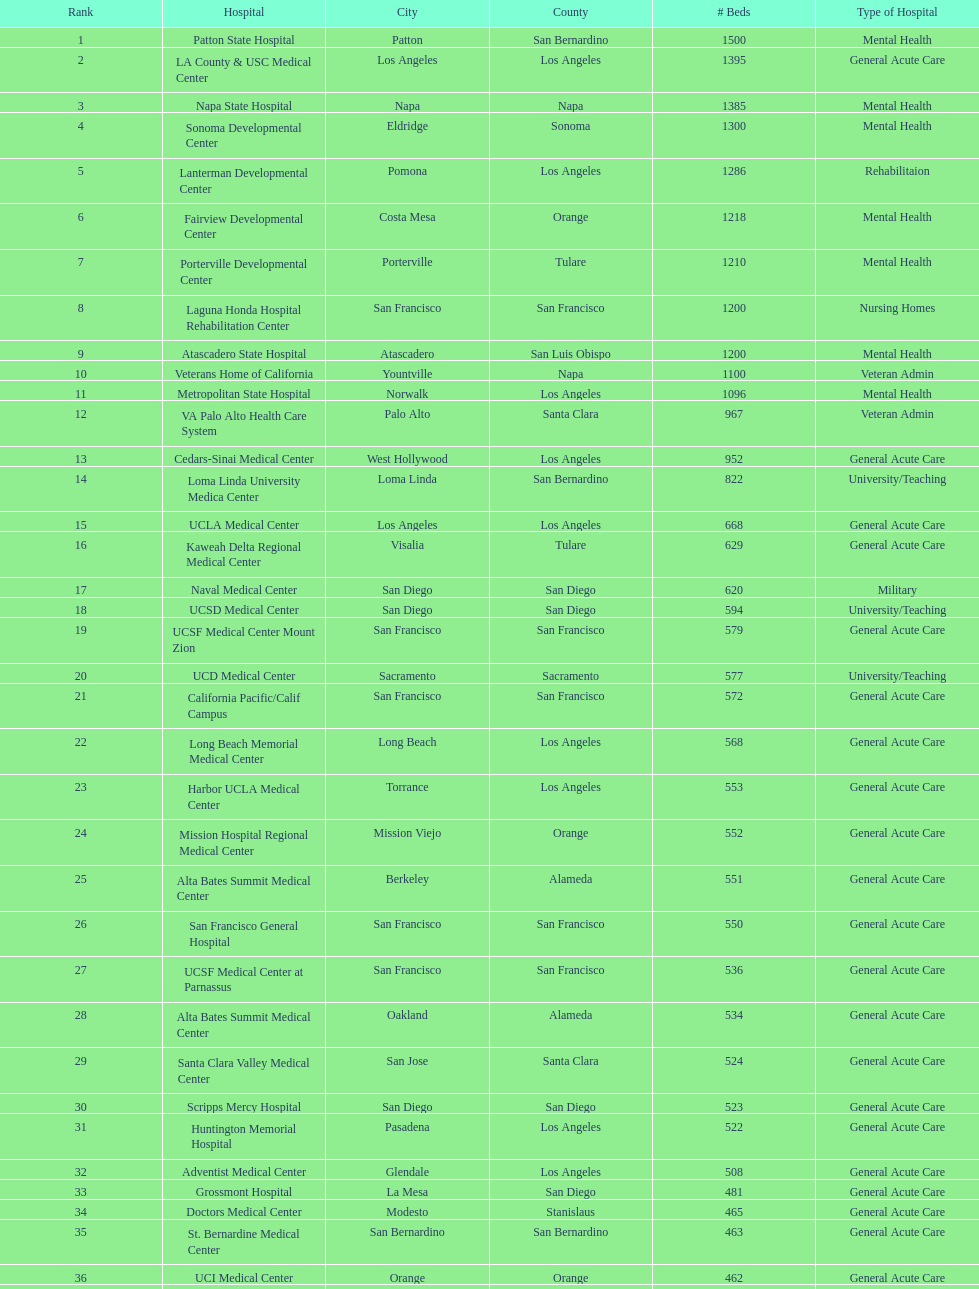Which type of hospitals are the same as grossmont hospital? General Acute Care. 